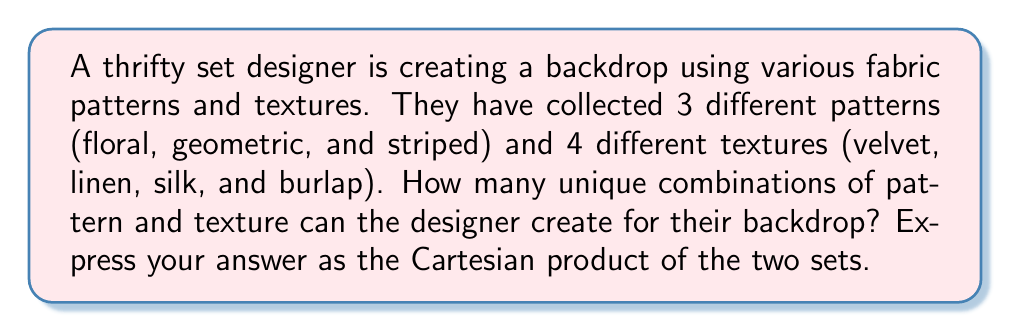Give your solution to this math problem. To solve this problem, we need to understand the concept of Cartesian product and how it applies to our sets of fabric patterns and textures.

1. Let's define our sets:
   P = {floral, geometric, striped} (patterns)
   T = {velvet, linen, silk, burlap} (textures)

2. The Cartesian product of two sets A and B, denoted as A × B, is the set of all ordered pairs (a, b) where a ∈ A and b ∈ B.

3. In this case, we want to find P × T, which will give us all possible combinations of patterns and textures.

4. To calculate the number of elements in the Cartesian product, we multiply the number of elements in each set:
   |P × T| = |P| × |T|
   
   Where |P| is the number of elements in set P, and |T| is the number of elements in set T.

5. We have:
   |P| = 3 (floral, geometric, striped)
   |T| = 4 (velvet, linen, silk, burlap)

6. Therefore:
   |P × T| = 3 × 4 = 12

7. The Cartesian product P × T can be written out as:
   P × T = {(floral, velvet), (floral, linen), (floral, silk), (floral, burlap),
             (geometric, velvet), (geometric, linen), (geometric, silk), (geometric, burlap),
             (striped, velvet), (striped, linen), (striped, silk), (striped, burlap)}

This means the set designer can create 12 unique combinations of pattern and texture for their backdrop.
Answer: P × T, where |P × T| = 12 